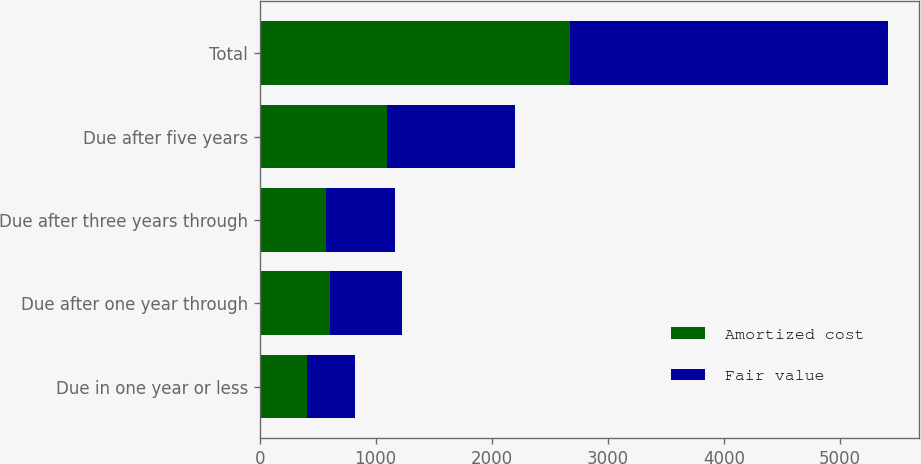Convert chart to OTSL. <chart><loc_0><loc_0><loc_500><loc_500><stacked_bar_chart><ecel><fcel>Due in one year or less<fcel>Due after one year through<fcel>Due after three years through<fcel>Due after five years<fcel>Total<nl><fcel>Amortized cost<fcel>408.7<fcel>603<fcel>570.8<fcel>1095.4<fcel>2677.9<nl><fcel>Fair value<fcel>412.3<fcel>626.9<fcel>592.7<fcel>1105.3<fcel>2737.2<nl></chart> 